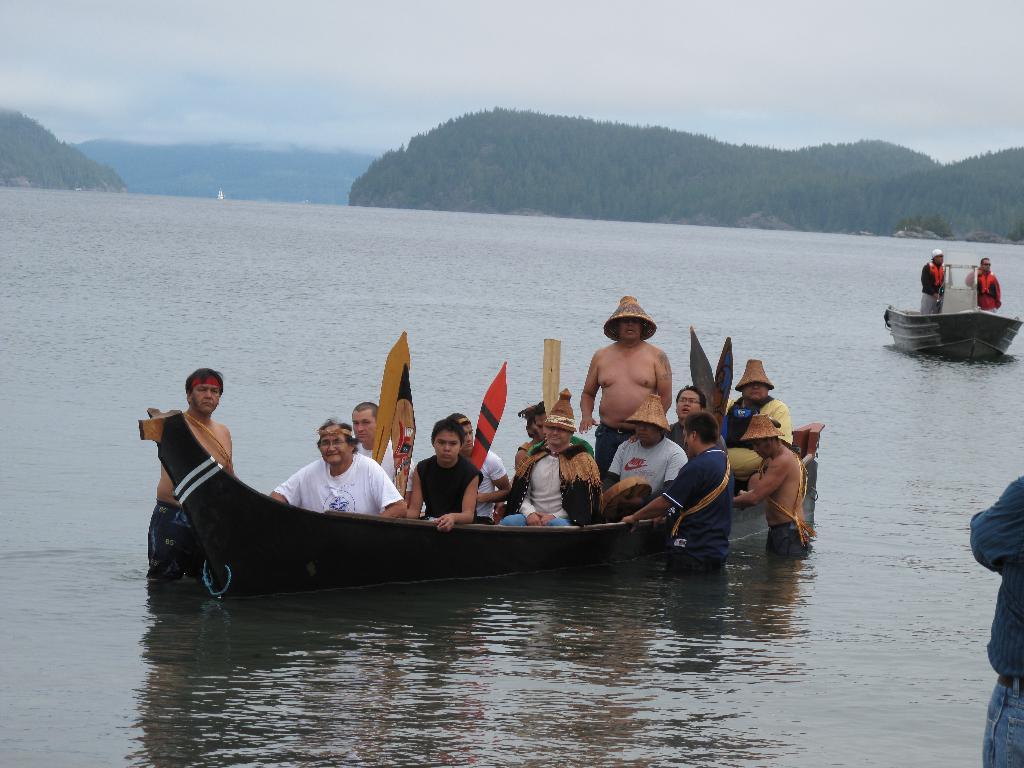How would you summarize this image in a sentence or two? A group of people sailing in the boat,Right side of the boat two people are standing and holding the boat, A group of hills beside a river and a very cloudy sky. 